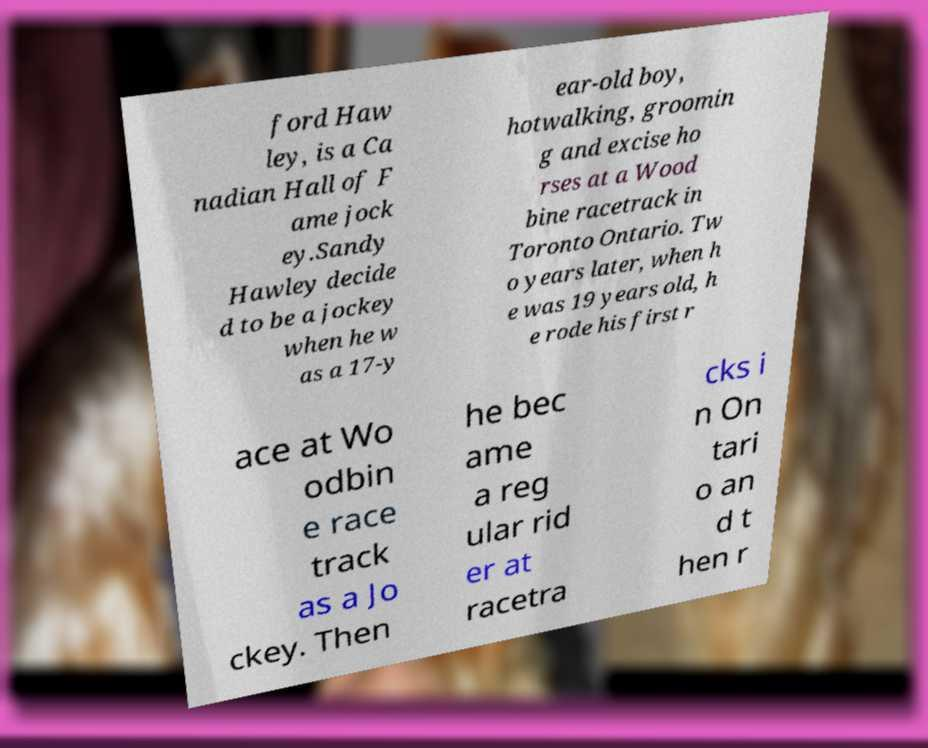What messages or text are displayed in this image? I need them in a readable, typed format. ford Haw ley, is a Ca nadian Hall of F ame jock ey.Sandy Hawley decide d to be a jockey when he w as a 17-y ear-old boy, hotwalking, groomin g and excise ho rses at a Wood bine racetrack in Toronto Ontario. Tw o years later, when h e was 19 years old, h e rode his first r ace at Wo odbin e race track as a Jo ckey. Then he bec ame a reg ular rid er at racetra cks i n On tari o an d t hen r 